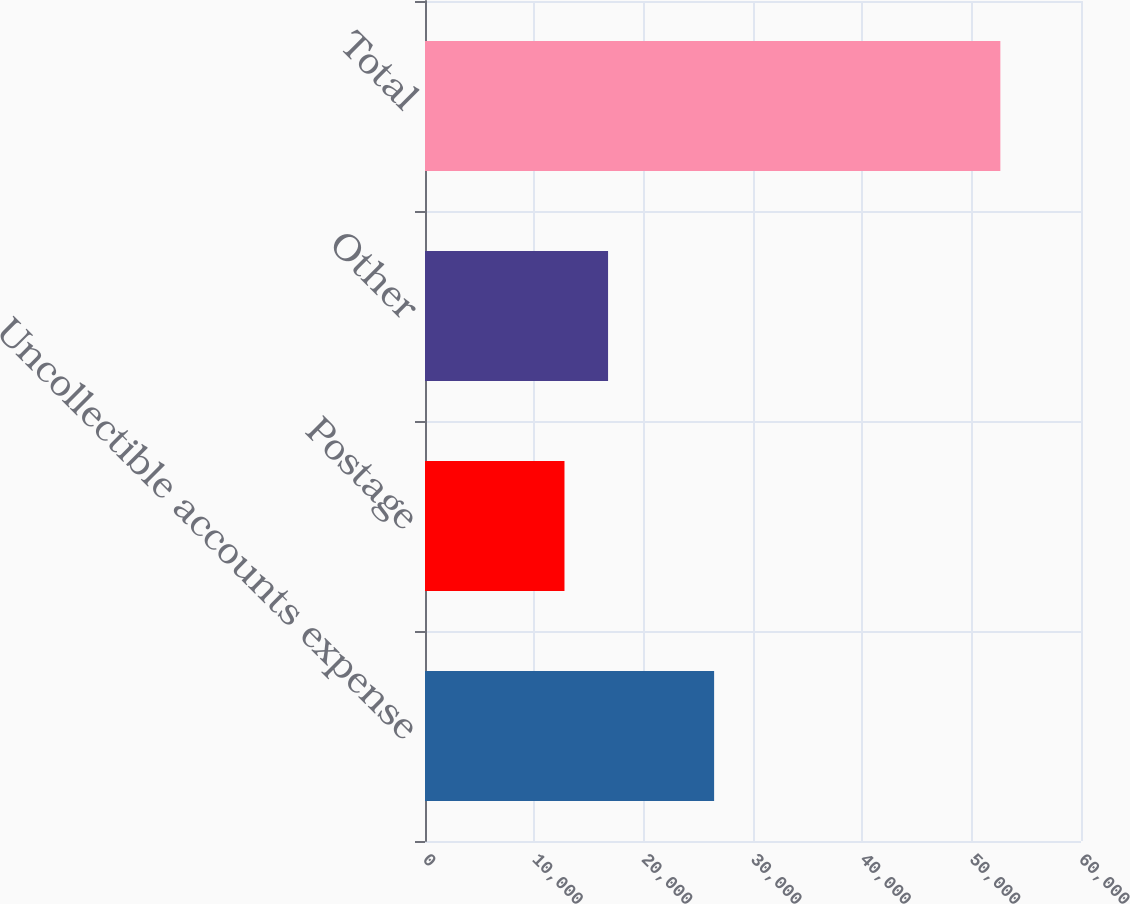Convert chart. <chart><loc_0><loc_0><loc_500><loc_500><bar_chart><fcel>Uncollectible accounts expense<fcel>Postage<fcel>Other<fcel>Total<nl><fcel>26443<fcel>12757<fcel>16743.8<fcel>52625<nl></chart> 